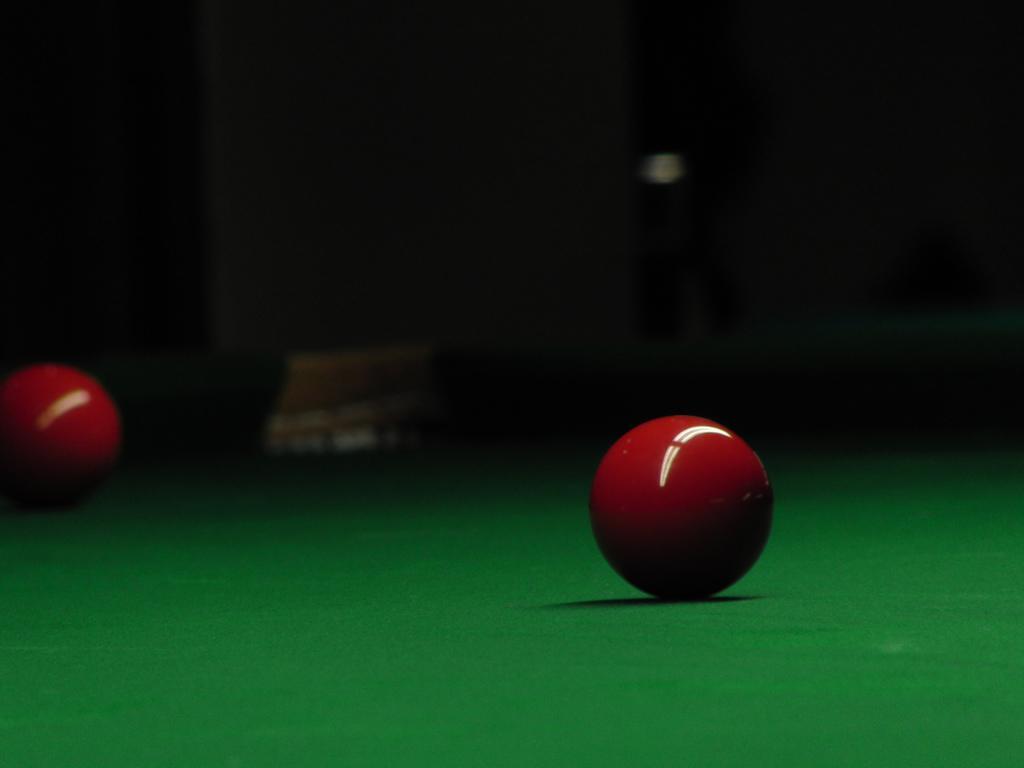Please provide a concise description of this image. In the foreground we can see a ball. In this picture we can see a green color object. It might be table. The background is dark. On the left we can see a red color ball. 